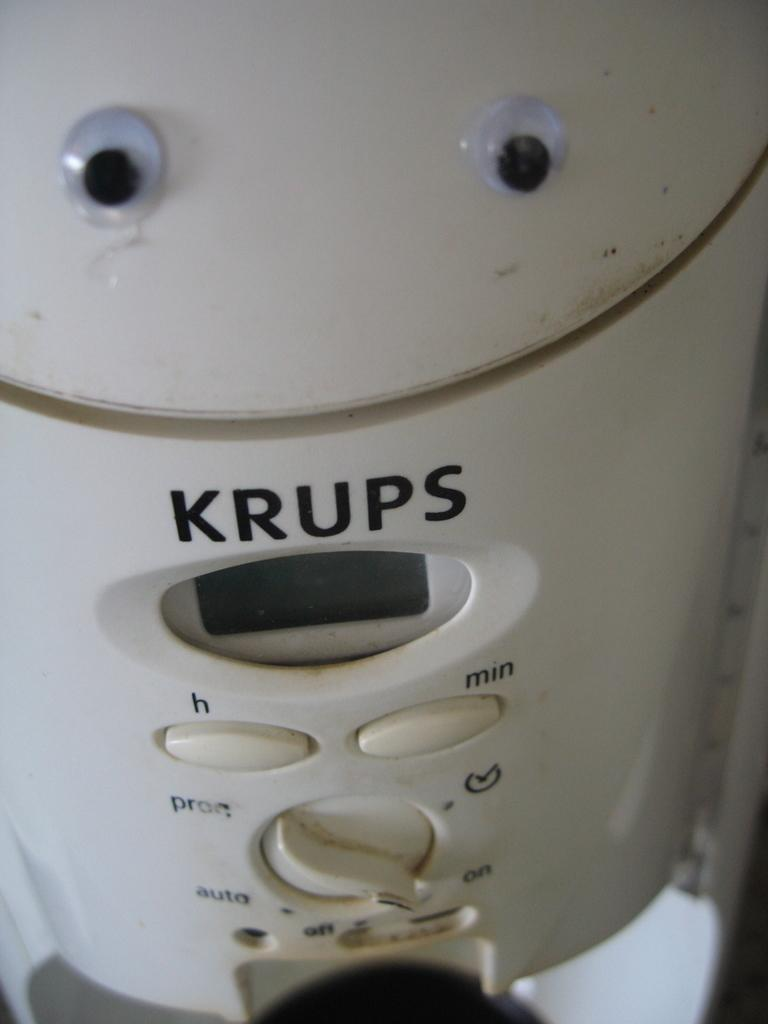<image>
Render a clear and concise summary of the photo. A white KRUPS device with H and Min buttons and a deal for on/off/auto. 